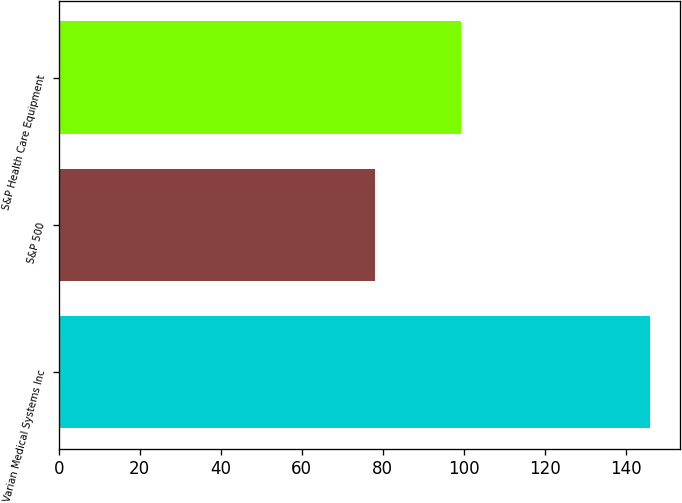Convert chart. <chart><loc_0><loc_0><loc_500><loc_500><bar_chart><fcel>Varian Medical Systems Inc<fcel>S&P 500<fcel>S&P Health Care Equipment<nl><fcel>146.05<fcel>78.02<fcel>99.37<nl></chart> 